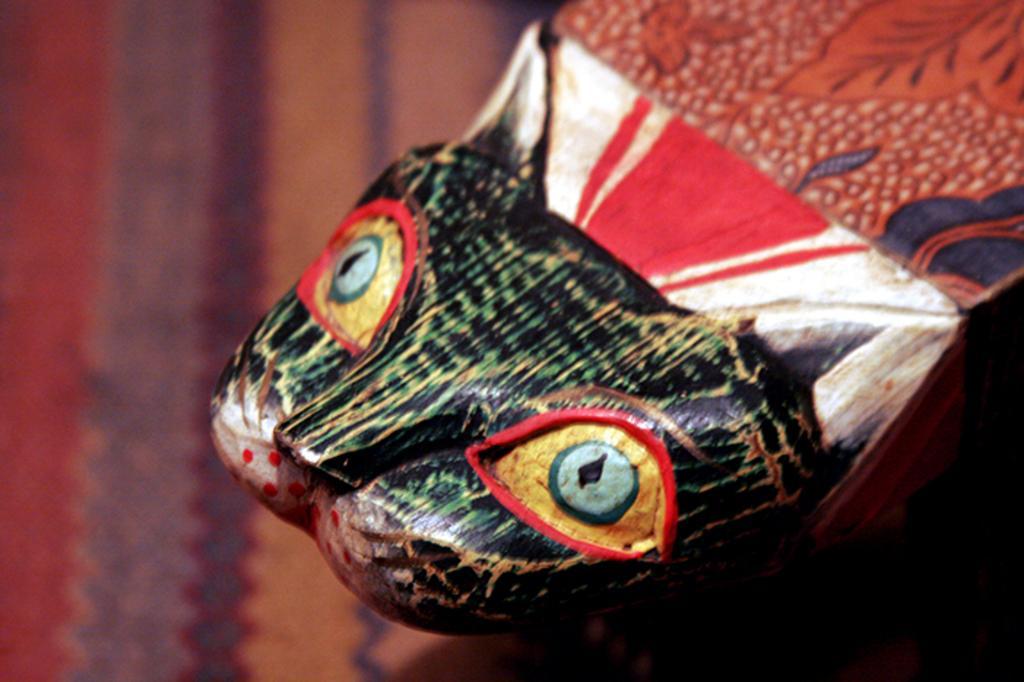Could you give a brief overview of what you see in this image? In this image, we can see an object that looks like a fish. We can also see the ground. 